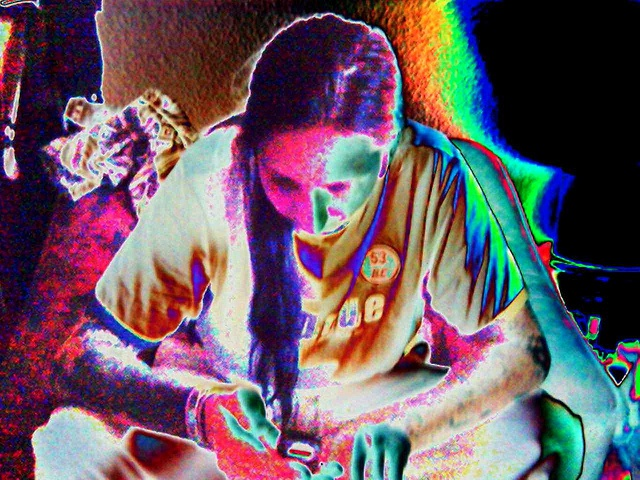Describe the objects in this image and their specific colors. I can see people in khaki, lightgray, black, lightblue, and navy tones and cell phone in khaki, lightgray, black, and purple tones in this image. 